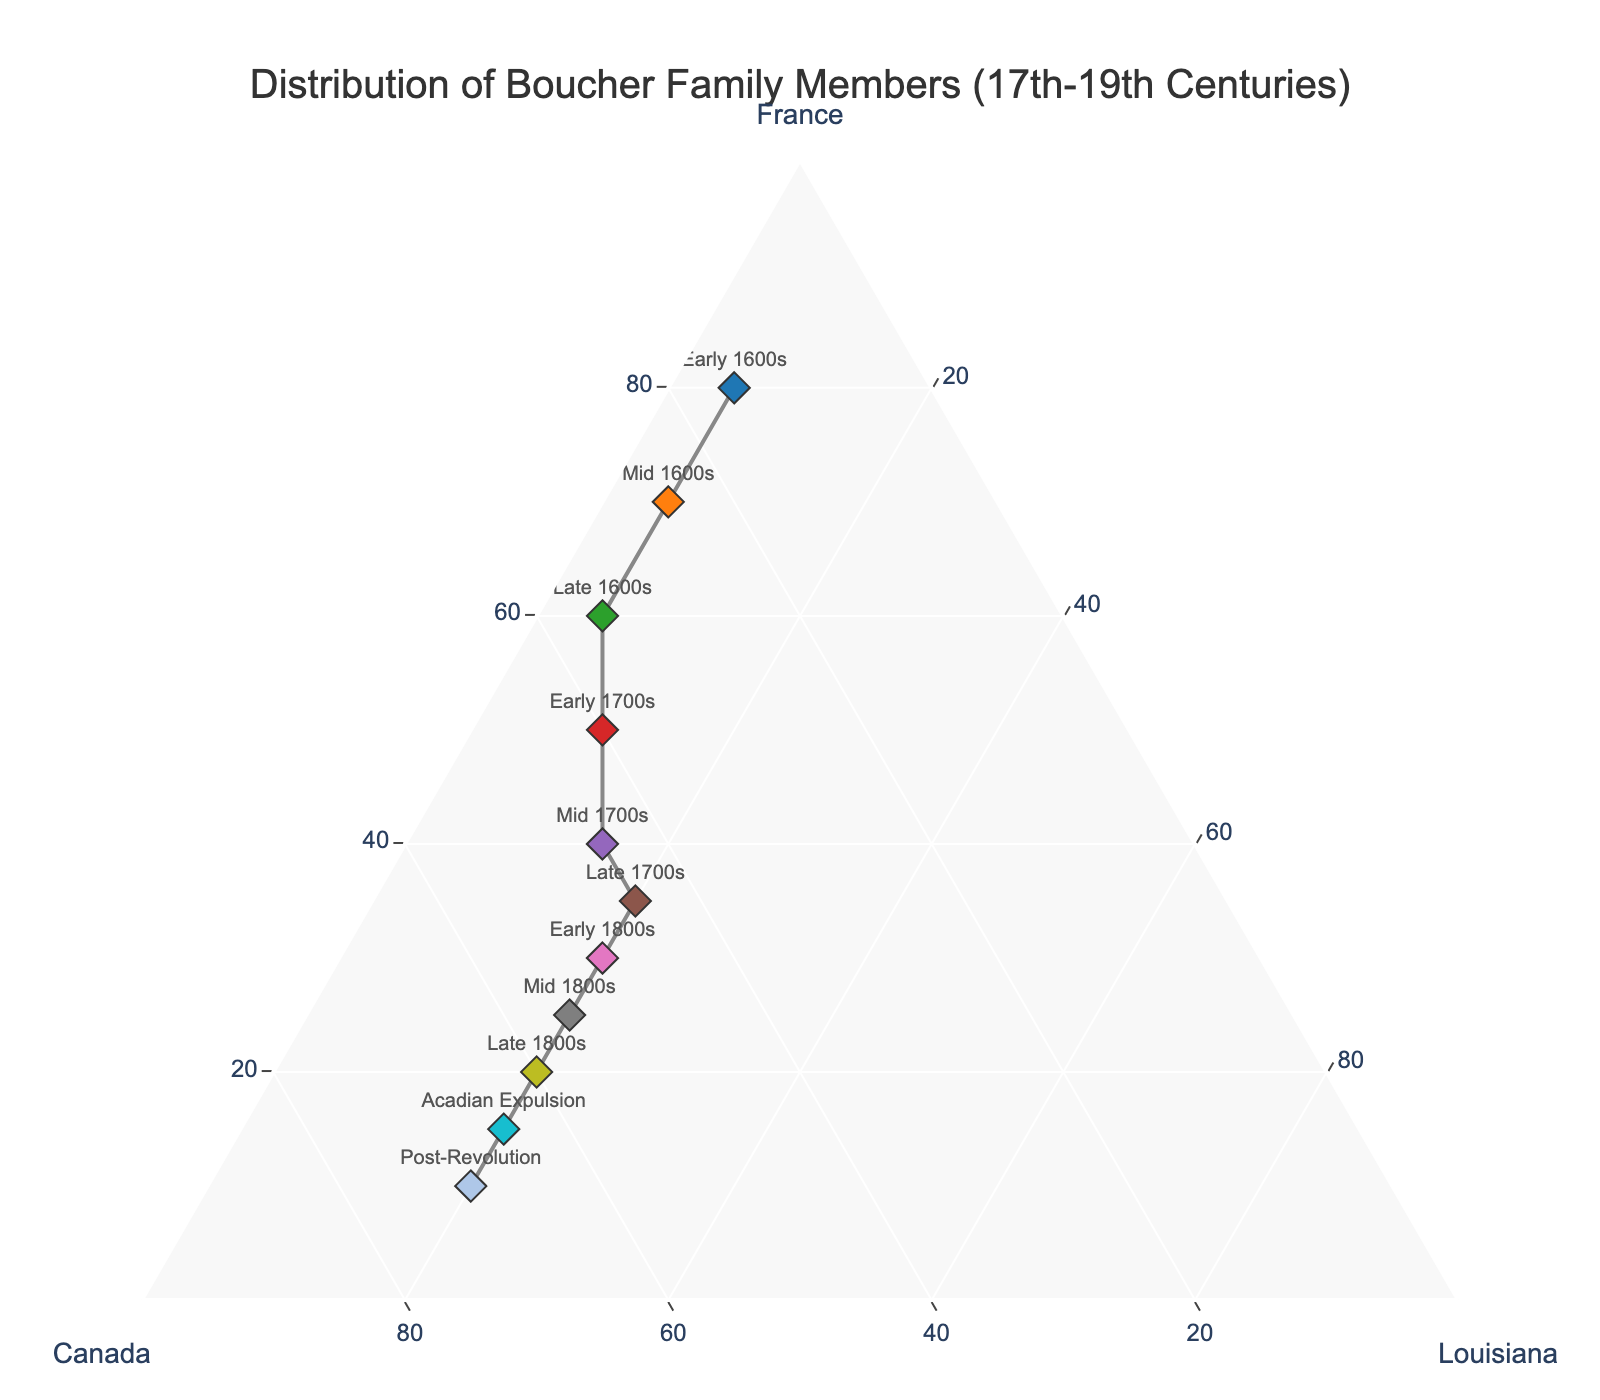Which region has the highest percentage of Boucher family members in the Early 1600s? Looking at the data point labeled "Early 1600s," the region with the highest percentage is the one farthest along that axis. In this case, it is France.
Answer: France How did the distribution of Boucher family members change from the Early 1700s to the Post-Revolution period? Comparing the data points for "Early 1700s" and "Post-Revolution," the percentage of family members in France decreased from 50% to 10%, while those in Canada increased from 40% to 70%. Louisiana remained mostly stable with a slight increase from 10% to 20%.
Answer: Decreased in France, increased in Canada, stable in Louisiana How many regions show a decrease in Boucher family members over time? By following the markers from the Early 1600s to the Post-Revolution period, we observe that the number of family members in France decreases continuously. Neither Canada nor Louisiana show a consistent decrease over this period.
Answer: 1 (France) Which time period shows the most balanced distribution across France, Canada, and Louisiana? A balanced distribution would be one where the data point is closer to the center of the ternary plot. The "Late 1700s" period data point appears to be the most balanced among France (35%), Canada (45%), and Louisiana (20%).
Answer: Late 1700s Between which two periods does Canada see the most significant increase in Boucher family presence? According to the markers, the most significant increase in Canada's percentage of Boucher family members occurs between the "Early 1700s" (40%) and "Mid 1700s" (45%), but the biggest jump is between "Mid 1800s" (55%) and "Late 1800s" (60%).
Answer: Between Mid 1800s and Late 1800s In the Mid 1600s, what is the combined percentage of Boucher family members in Canada and Louisiana? Referring to the Mid 1600s data point, the percentage in Canada is 25 and Louisiana is 5. Adding these together gives a total of 25 + 5 = 30%.
Answer: 30% Which region has the smallest percentage of Boucher family members during the Acadian Expulsion? Looking at the Acadian Expulsion data point, the region with the smallest percentage is France, with 15%.
Answer: France During which period does France first drop below 50% of the total distribution? Monitoring the points, we see that France first drops below 50% in the Early 1700s when it stands at 50%. The first period below 50% is the Mid 1700s (40%).
Answer: Mid 1700s What overall trend can you observe about the presence of Boucher family members in Louisiana over time? Observing the data points chronologically, the presence of Boucher family members in Louisiana generally increases from 5% in the Early 1600s to a stable 20% from the Late 1700s onward.
Answer: Generally increases to 20% from Late 1700s onward 